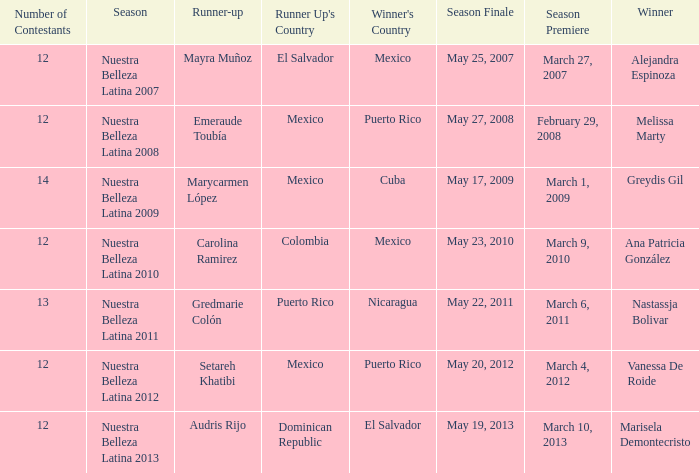What season had more than 12 contestants in which greydis gil won? Nuestra Belleza Latina 2009. 